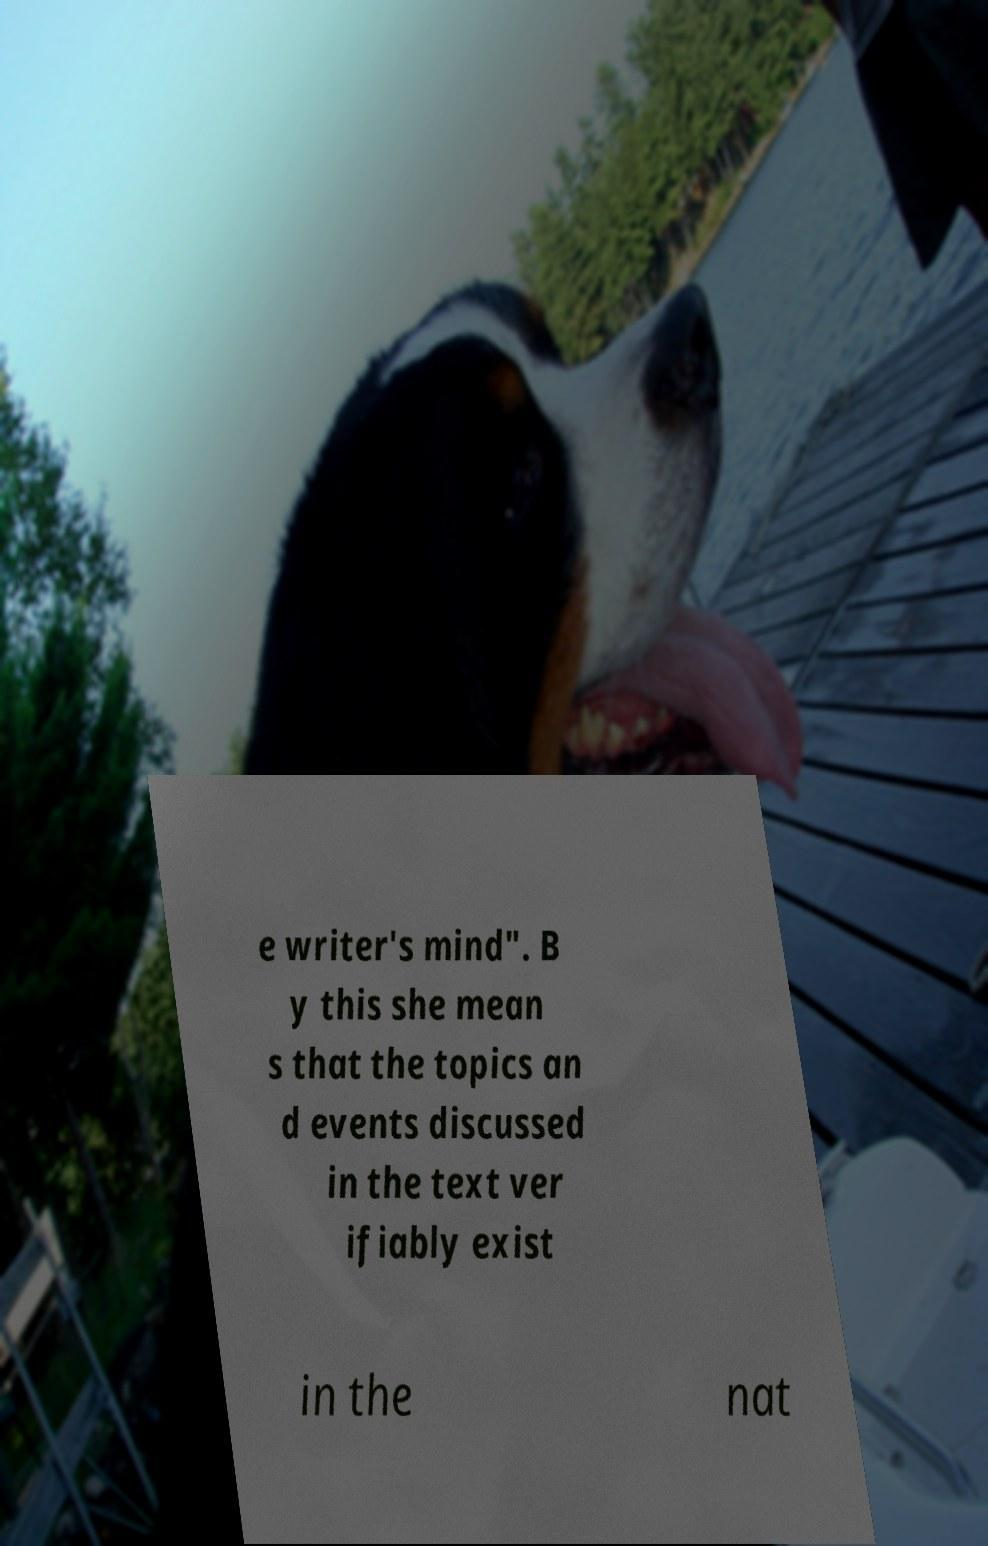Can you accurately transcribe the text from the provided image for me? e writer's mind". B y this she mean s that the topics an d events discussed in the text ver ifiably exist in the nat 